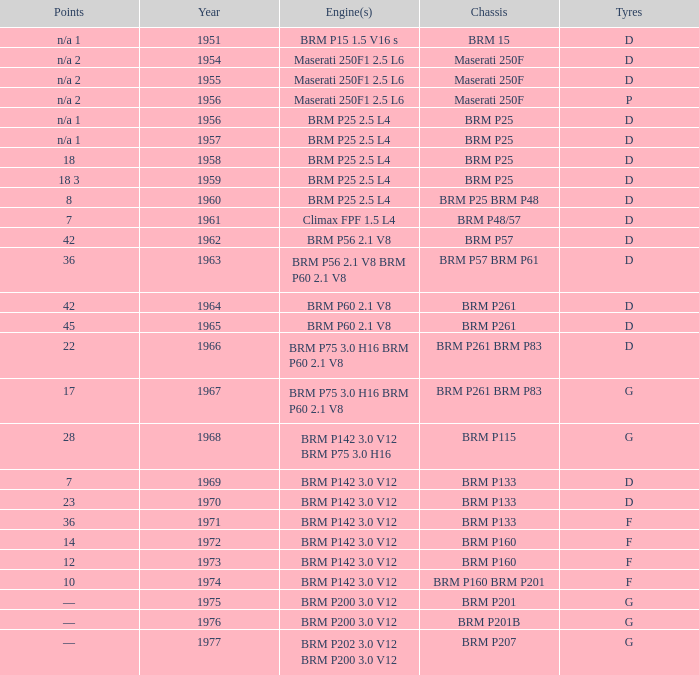Name the point for 1974 10.0. 